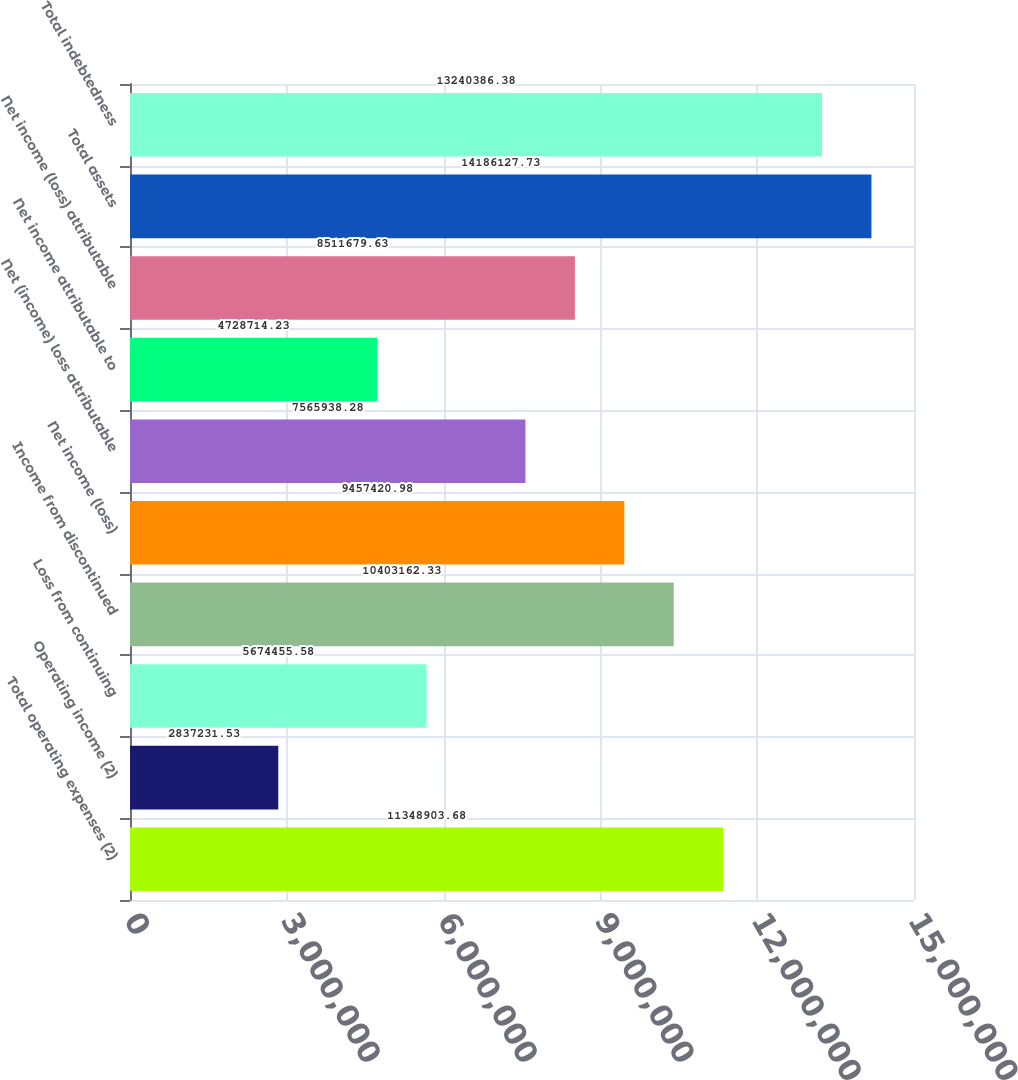<chart> <loc_0><loc_0><loc_500><loc_500><bar_chart><fcel>Total operating expenses (2)<fcel>Operating income (2)<fcel>Loss from continuing<fcel>Income from discontinued<fcel>Net income (loss)<fcel>Net (income) loss attributable<fcel>Net income attributable to<fcel>Net income (loss) attributable<fcel>Total assets<fcel>Total indebtedness<nl><fcel>1.13489e+07<fcel>2.83723e+06<fcel>5.67446e+06<fcel>1.04032e+07<fcel>9.45742e+06<fcel>7.56594e+06<fcel>4.72871e+06<fcel>8.51168e+06<fcel>1.41861e+07<fcel>1.32404e+07<nl></chart> 